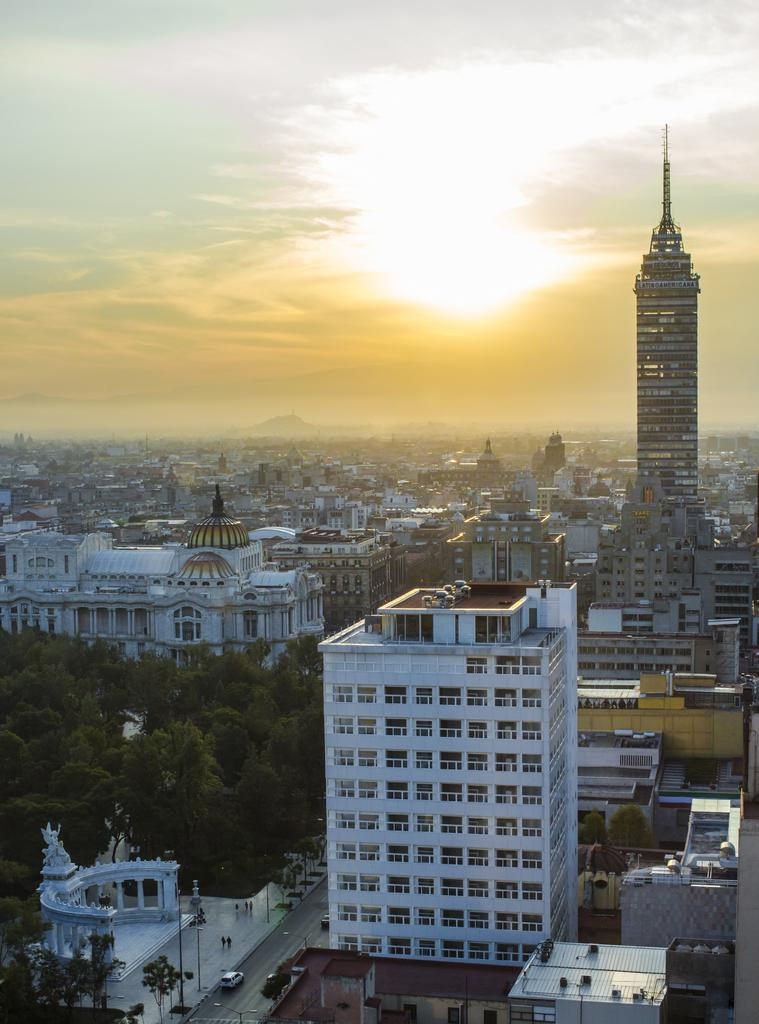What type of structures can be seen in the image? There are buildings in the image. What other natural elements are present in the image? There are trees in the image. What is the purpose of the road in the image? The road is used for vehicles to travel on. What can be seen on the road in the image? There are vehicles on the road. What is visible in the background of the image? The sky, a mountain, and the sun are visible in the background of the image. Where is the snail going to attend the meeting in the image? There is no snail or meeting present in the image. What type of love is expressed by the trees in the image? The trees in the image do not express any type of love; they are simply natural elements in the scene. 